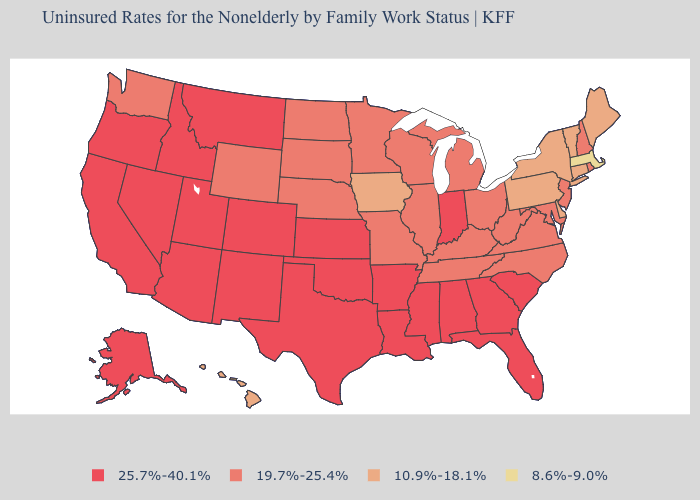What is the lowest value in the South?
Answer briefly. 10.9%-18.1%. What is the value of Wyoming?
Answer briefly. 19.7%-25.4%. Name the states that have a value in the range 10.9%-18.1%?
Write a very short answer. Connecticut, Delaware, Hawaii, Iowa, Maine, New York, Pennsylvania, Vermont. Among the states that border Florida , which have the highest value?
Quick response, please. Alabama, Georgia. What is the value of Texas?
Answer briefly. 25.7%-40.1%. What is the lowest value in the Northeast?
Give a very brief answer. 8.6%-9.0%. What is the value of New Mexico?
Write a very short answer. 25.7%-40.1%. How many symbols are there in the legend?
Be succinct. 4. Name the states that have a value in the range 10.9%-18.1%?
Quick response, please. Connecticut, Delaware, Hawaii, Iowa, Maine, New York, Pennsylvania, Vermont. Name the states that have a value in the range 25.7%-40.1%?
Be succinct. Alabama, Alaska, Arizona, Arkansas, California, Colorado, Florida, Georgia, Idaho, Indiana, Kansas, Louisiana, Mississippi, Montana, Nevada, New Mexico, Oklahoma, Oregon, South Carolina, Texas, Utah. Name the states that have a value in the range 8.6%-9.0%?
Give a very brief answer. Massachusetts. Name the states that have a value in the range 19.7%-25.4%?
Keep it brief. Illinois, Kentucky, Maryland, Michigan, Minnesota, Missouri, Nebraska, New Hampshire, New Jersey, North Carolina, North Dakota, Ohio, Rhode Island, South Dakota, Tennessee, Virginia, Washington, West Virginia, Wisconsin, Wyoming. What is the value of Michigan?
Short answer required. 19.7%-25.4%. What is the value of Alaska?
Short answer required. 25.7%-40.1%. What is the value of Ohio?
Keep it brief. 19.7%-25.4%. 